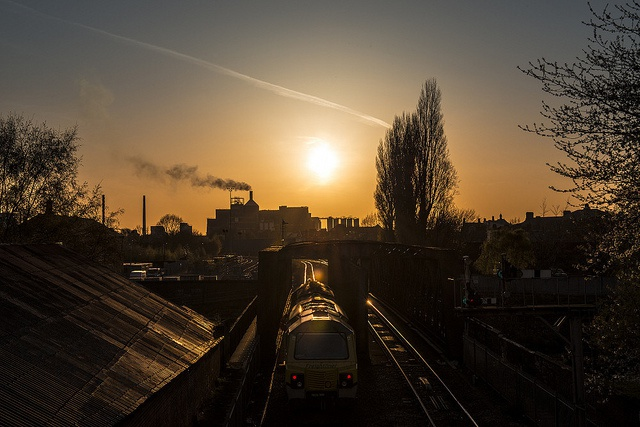Describe the objects in this image and their specific colors. I can see train in purple, black, maroon, and olive tones, truck in purple, black, maroon, and khaki tones, traffic light in purple, black, maroon, and gray tones, traffic light in black, teal, darkgreen, and purple tones, and traffic light in black, maroon, brown, and purple tones in this image. 